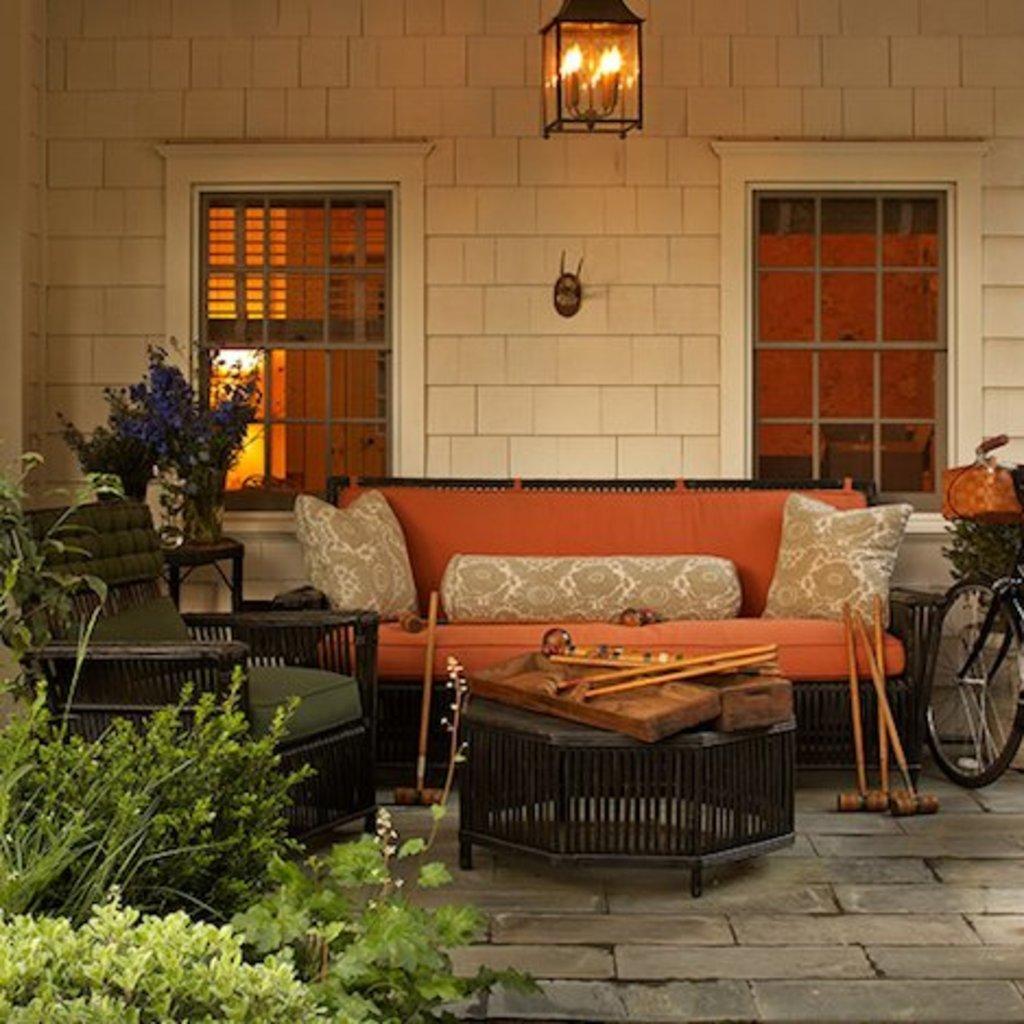How would you summarize this image in a sentence or two? There is a room. There is a sofa and chair. We can see in background wall and window. On the right side we have a bicycle. On the left side we have a plants. 